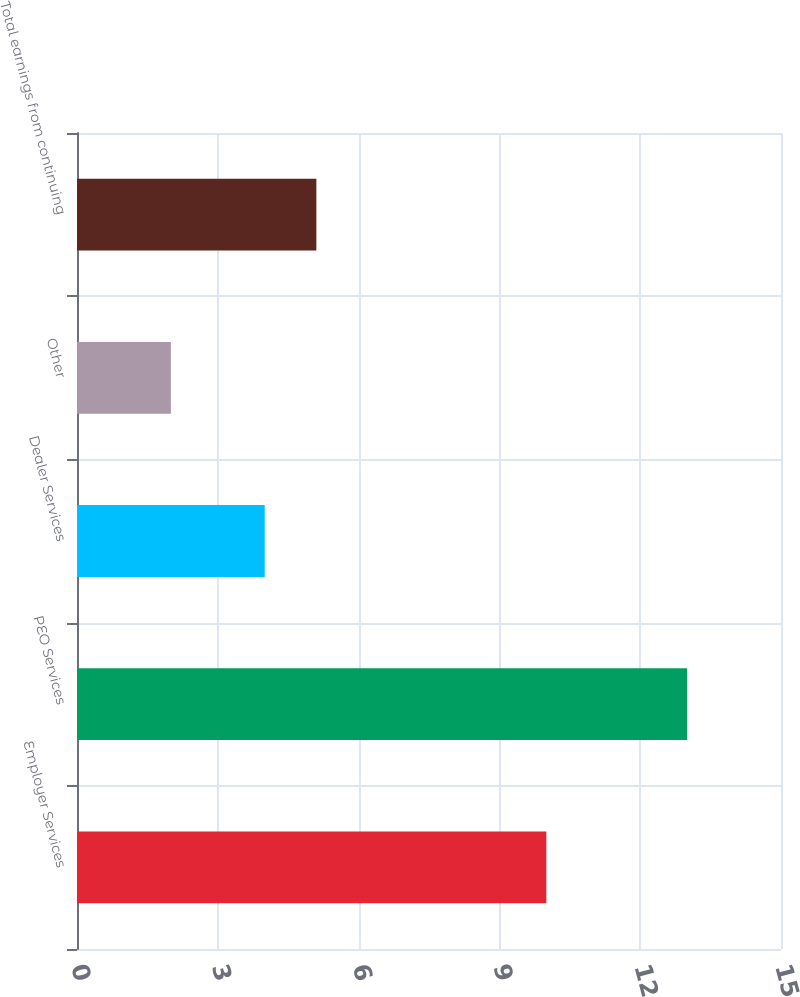<chart> <loc_0><loc_0><loc_500><loc_500><bar_chart><fcel>Employer Services<fcel>PEO Services<fcel>Dealer Services<fcel>Other<fcel>Total earnings from continuing<nl><fcel>10<fcel>13<fcel>4<fcel>2<fcel>5.1<nl></chart> 